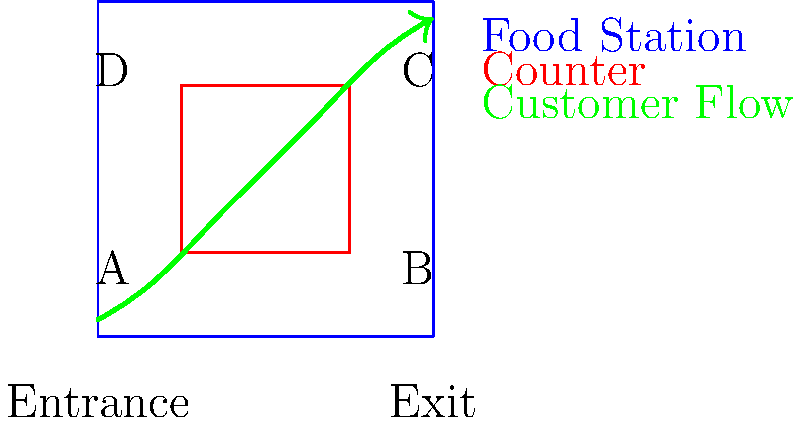In the self-service food station layout shown above, customers typically move in a clockwise direction. If we represent this flow as a graph, with nodes A, B, C, and D representing the corners of the food counter, what is the maximum number of edges that can be removed while still allowing customers to reach all stations? To solve this problem, let's follow these steps:

1) First, we need to represent the customer flow as a graph:
   - Nodes: A, B, C, D (corners of the food counter)
   - Edges: AB, BC, CD, DA (representing possible movements between stations)

2) The graph forms a cycle: A -> B -> C -> D -> A

3) In a cycle with $n$ nodes, there are $n$ edges.

4) To ensure all stations are reachable, we need at least $n-1$ edges to form a spanning tree.

5) In this case, $n = 4$, so we need at least 3 edges to keep all stations connected.

6) The maximum number of edges that can be removed is the difference between the total number of edges and the minimum required:

   $\text{Max removable edges} = \text{Total edges} - \text{Minimum required edges}$
   $= 4 - 3 = 1$

Therefore, we can remove at most 1 edge while still ensuring all stations are reachable.
Answer: 1 